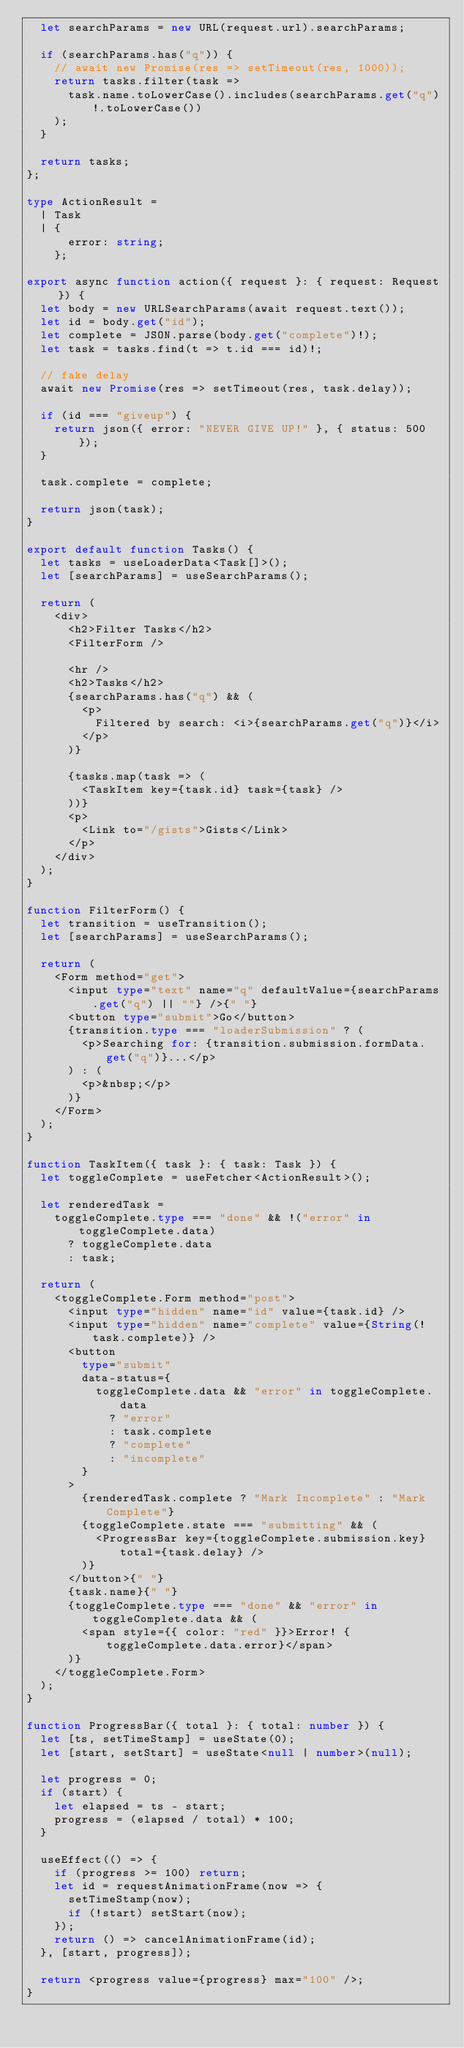<code> <loc_0><loc_0><loc_500><loc_500><_TypeScript_>  let searchParams = new URL(request.url).searchParams;

  if (searchParams.has("q")) {
    // await new Promise(res => setTimeout(res, 1000));
    return tasks.filter(task =>
      task.name.toLowerCase().includes(searchParams.get("q")!.toLowerCase())
    );
  }

  return tasks;
};

type ActionResult =
  | Task
  | {
      error: string;
    };

export async function action({ request }: { request: Request }) {
  let body = new URLSearchParams(await request.text());
  let id = body.get("id");
  let complete = JSON.parse(body.get("complete")!);
  let task = tasks.find(t => t.id === id)!;

  // fake delay
  await new Promise(res => setTimeout(res, task.delay));

  if (id === "giveup") {
    return json({ error: "NEVER GIVE UP!" }, { status: 500 });
  }

  task.complete = complete;

  return json(task);
}

export default function Tasks() {
  let tasks = useLoaderData<Task[]>();
  let [searchParams] = useSearchParams();

  return (
    <div>
      <h2>Filter Tasks</h2>
      <FilterForm />

      <hr />
      <h2>Tasks</h2>
      {searchParams.has("q") && (
        <p>
          Filtered by search: <i>{searchParams.get("q")}</i>
        </p>
      )}

      {tasks.map(task => (
        <TaskItem key={task.id} task={task} />
      ))}
      <p>
        <Link to="/gists">Gists</Link>
      </p>
    </div>
  );
}

function FilterForm() {
  let transition = useTransition();
  let [searchParams] = useSearchParams();

  return (
    <Form method="get">
      <input type="text" name="q" defaultValue={searchParams.get("q") || ""} />{" "}
      <button type="submit">Go</button>
      {transition.type === "loaderSubmission" ? (
        <p>Searching for: {transition.submission.formData.get("q")}...</p>
      ) : (
        <p>&nbsp;</p>
      )}
    </Form>
  );
}

function TaskItem({ task }: { task: Task }) {
  let toggleComplete = useFetcher<ActionResult>();

  let renderedTask =
    toggleComplete.type === "done" && !("error" in toggleComplete.data)
      ? toggleComplete.data
      : task;

  return (
    <toggleComplete.Form method="post">
      <input type="hidden" name="id" value={task.id} />
      <input type="hidden" name="complete" value={String(!task.complete)} />
      <button
        type="submit"
        data-status={
          toggleComplete.data && "error" in toggleComplete.data
            ? "error"
            : task.complete
            ? "complete"
            : "incomplete"
        }
      >
        {renderedTask.complete ? "Mark Incomplete" : "Mark Complete"}
        {toggleComplete.state === "submitting" && (
          <ProgressBar key={toggleComplete.submission.key} total={task.delay} />
        )}
      </button>{" "}
      {task.name}{" "}
      {toggleComplete.type === "done" && "error" in toggleComplete.data && (
        <span style={{ color: "red" }}>Error! {toggleComplete.data.error}</span>
      )}
    </toggleComplete.Form>
  );
}

function ProgressBar({ total }: { total: number }) {
  let [ts, setTimeStamp] = useState(0);
  let [start, setStart] = useState<null | number>(null);

  let progress = 0;
  if (start) {
    let elapsed = ts - start;
    progress = (elapsed / total) * 100;
  }

  useEffect(() => {
    if (progress >= 100) return;
    let id = requestAnimationFrame(now => {
      setTimeStamp(now);
      if (!start) setStart(now);
    });
    return () => cancelAnimationFrame(id);
  }, [start, progress]);

  return <progress value={progress} max="100" />;
}
</code> 